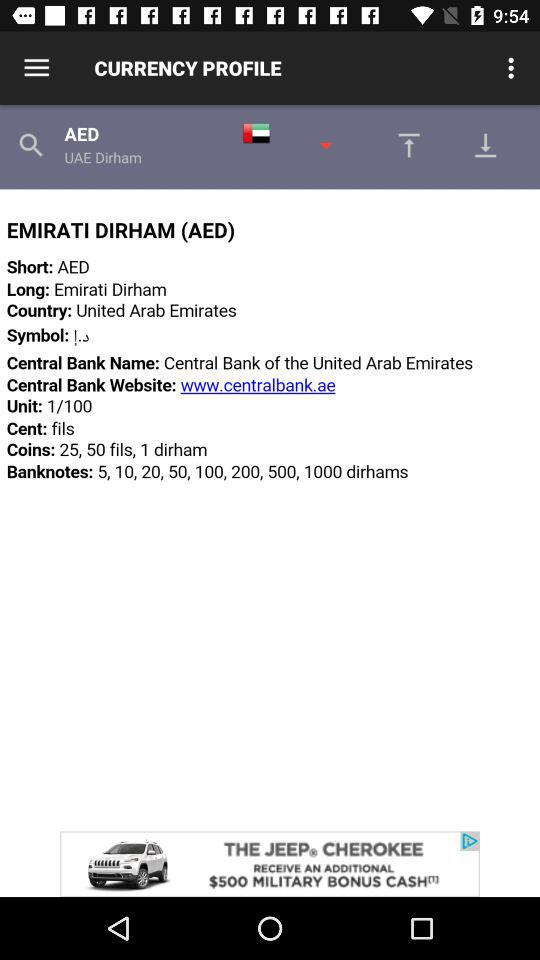What central bank website is given on the screen? The given website is www.centralbank.ae. 